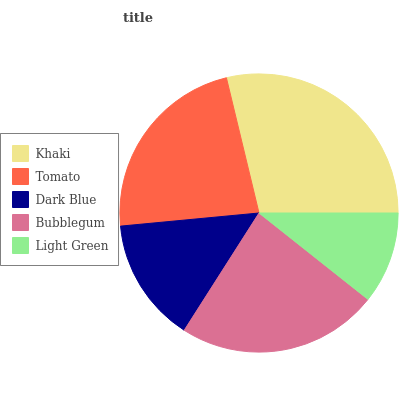Is Light Green the minimum?
Answer yes or no. Yes. Is Khaki the maximum?
Answer yes or no. Yes. Is Tomato the minimum?
Answer yes or no. No. Is Tomato the maximum?
Answer yes or no. No. Is Khaki greater than Tomato?
Answer yes or no. Yes. Is Tomato less than Khaki?
Answer yes or no. Yes. Is Tomato greater than Khaki?
Answer yes or no. No. Is Khaki less than Tomato?
Answer yes or no. No. Is Tomato the high median?
Answer yes or no. Yes. Is Tomato the low median?
Answer yes or no. Yes. Is Light Green the high median?
Answer yes or no. No. Is Light Green the low median?
Answer yes or no. No. 